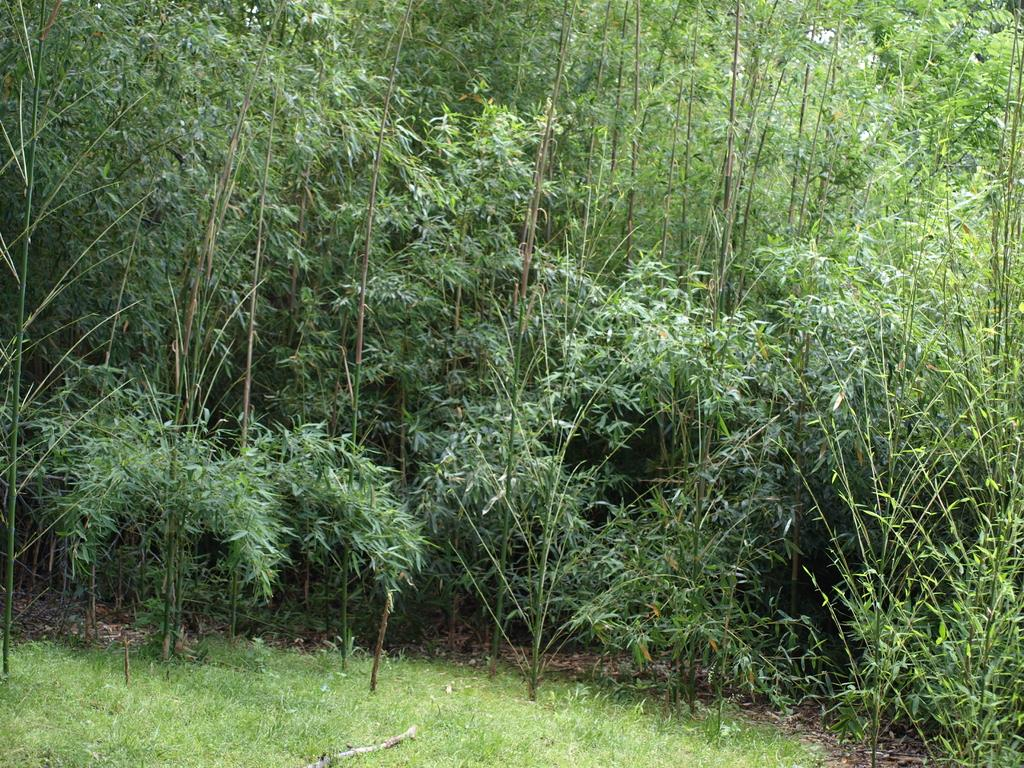What type of vegetation is present at the bottom of the image? There is grass on the ground at the bottom of the image. What other natural elements can be seen in the image? There are many trees in the image. What type of river can be seen flowing through the image? There is no river present in the image; it only features grass and trees. How many stars are visible in the image? There are no stars visible in the image, as it is focused on natural elements on the ground. 